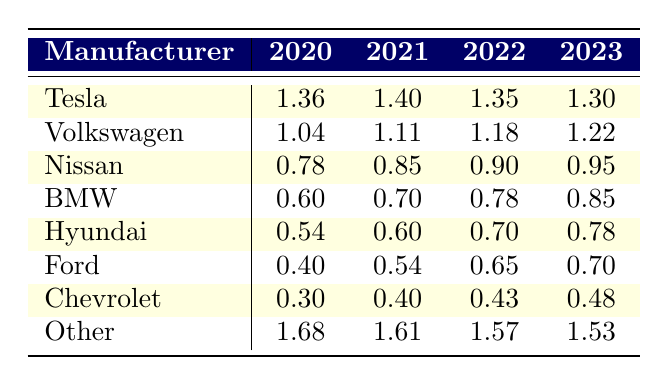What was Tesla's market share in 2022? Referring directly to the table, Tesla's market share in 2022 is listed as 22.5.
Answer: 22.5 Which manufacturer showed the largest increase in market share from 2020 to 2023? By comparing the values in each row for the respective years, Volkswagen increased from 11.0 in 2020 to 16.5 in 2023, showing a rise of 5.5. No other manufacturer had a higher increase over the same period.
Answer: Volkswagen Is Nissan's market share consistently increasing from 2020 to 2023? Looking at Nissan's values, it started at 6.0 in 2020, then increased to 7.0 in 2021, 8.0 in 2022, and finally 9.0 in 2023. Therefore, it shows a consistent increase across all years.
Answer: Yes What is the combined market share of Ford and Chevrolet in 2023? Ford's market share in 2023 is 5.0 and Chevrolet's is 3.0. Adding these two values gives 5.0 + 3.0 which equals 8.0.
Answer: 8.0 In which year did Tesla have the highest market share? Tesla had the highest market share in 2021, with a value of 25.0, which is greater than the values in 2020, 2022, and 2023.
Answer: 2021 Did the "Other" category decrease in market share from 2020 to 2023? The "Other" category started at 48.0 in 2020 and decreased to 33.5 in 2023. This indicates a decline over the three years.
Answer: Yes What is the average market share of BMW over the four years? BMW's market shares are 4.0, 5.0, 6.0, and 7.0 for 2020, 2021, 2022, and 2023 respectively. To find the average, we add these values (4.0 + 5.0 + 6.0 + 7.0 = 22.0) and divide by 4, giving 22.0 / 4 = 5.5.
Answer: 5.5 Who had the lowest market share in 2020 among the listed manufacturers? In 2020, Ford had a market share of 2.5, which is lower than that of all other listed manufacturers.
Answer: Ford What was the total market share percentage of the "Other" category from 2020 to 2023? The market shares of the "Other" category were 48.0 in 2020, 41.0 in 2021, 36.8 in 2022, and 33.5 in 2023. The total is calculated as (48.0 + 41.0 + 36.8 + 33.5 = 159.3).
Answer: 159.3 